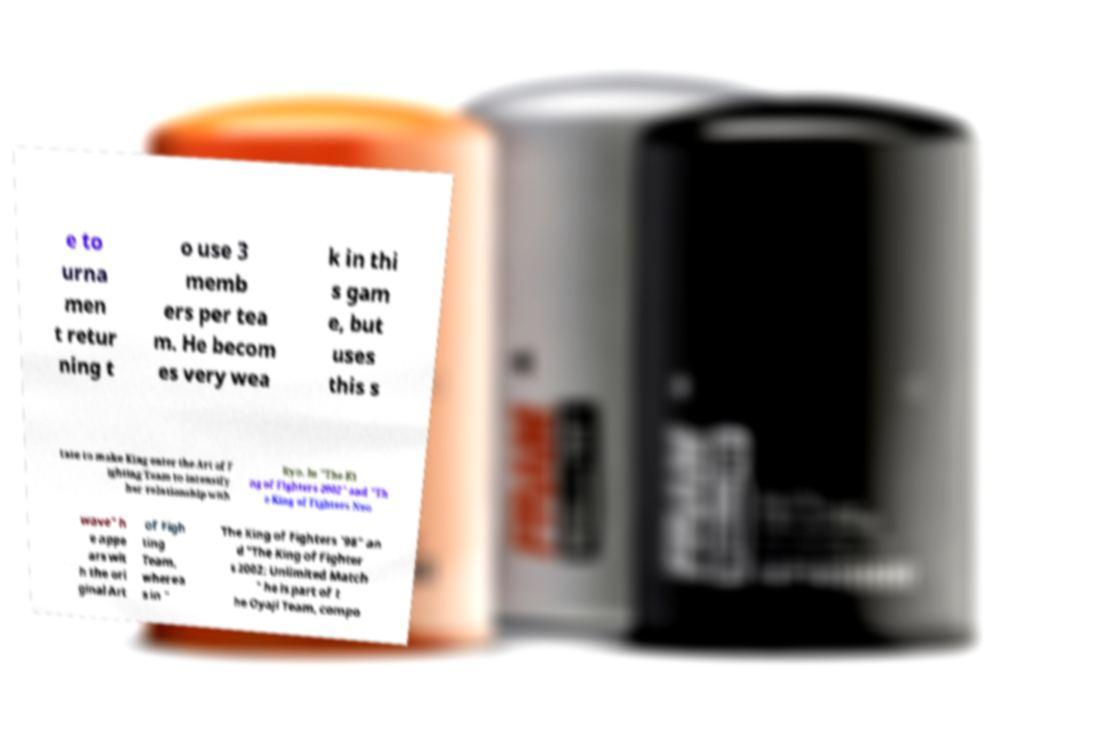Please identify and transcribe the text found in this image. e to urna men t retur ning t o use 3 memb ers per tea m. He becom es very wea k in thi s gam e, but uses this s tate to make King enter the Art of F ighting Team to intensify her relationship with Ryo. In "The Ki ng of Fighters 2002" and "Th e King of Fighters Neo wave" h e appe ars wit h the ori ginal Art of Figh ting Team, wherea s in " The King of Fighters '98" an d "The King of Fighter s 2002: Unlimited Match " he is part of t he Oyaji Team, compo 